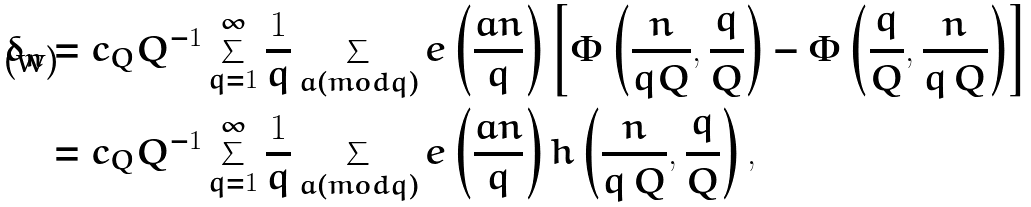<formula> <loc_0><loc_0><loc_500><loc_500>\delta _ { n } & = c _ { Q } Q ^ { - 1 } \sum _ { q = 1 } ^ { \infty } \frac { 1 } { q } \sum _ { a ( m o d q ) } e \left ( \frac { a n } { q } \right ) \left [ \Phi \left ( \frac { n } { q Q } , \frac { q } { Q } \right ) - \Phi \left ( \frac { q } { Q } , \frac { n } { q \, Q } \right ) \right ] \\ & = c _ { Q } Q ^ { - 1 } \sum _ { q = 1 } ^ { \infty } \frac { 1 } { q } \sum _ { a ( m o d q ) } e \left ( \frac { a n } { q } \right ) h \left ( \frac { n } { q \, Q } , \frac { q } { Q } \right ) ,</formula> 